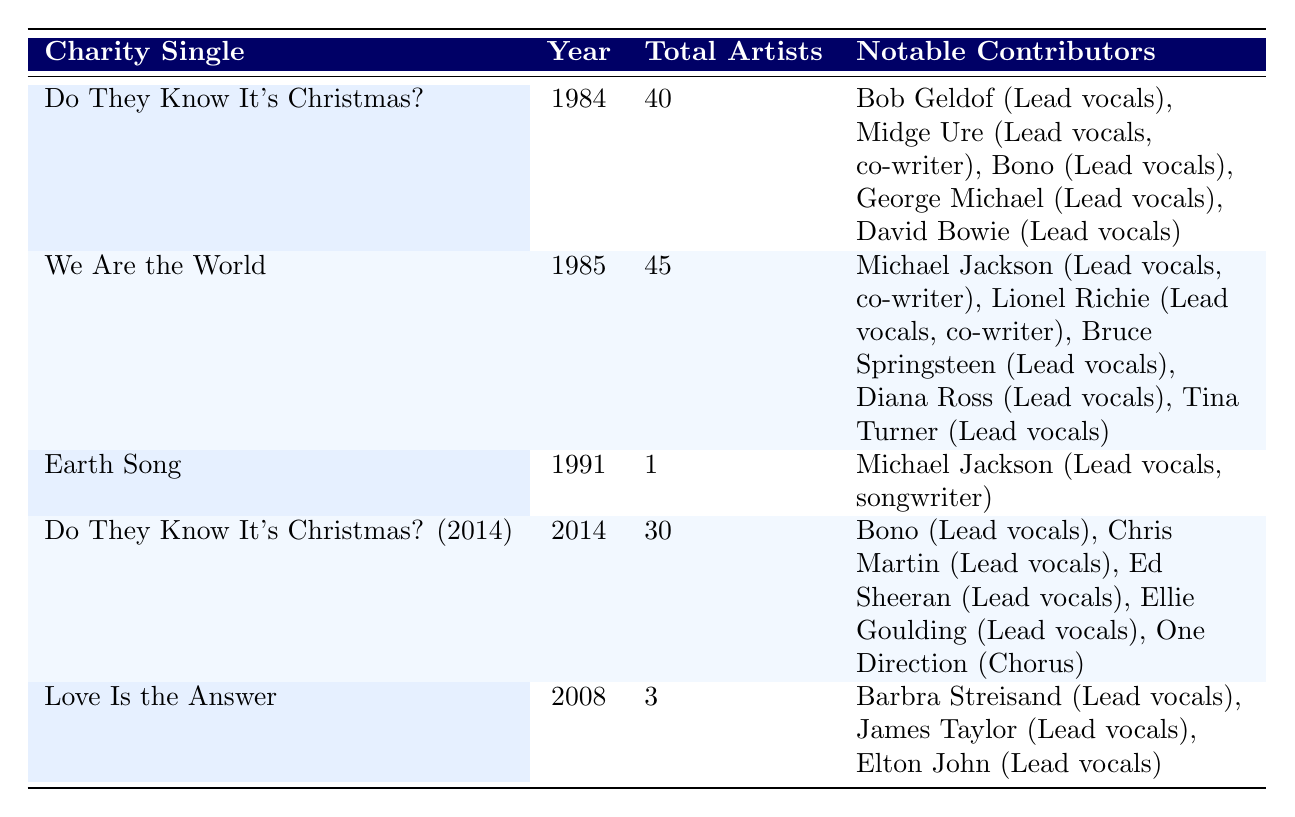What is the total number of artists involved in "We Are the World"? The table indicates that "We Are the World" has a total of 45 artists listed under the 'Total Artists' column.
Answer: 45 How many charity singles feature Michael Jackson? Michael Jackson is listed as a contributor for two charity singles: "We Are the World" and "Earth Song."
Answer: 2 Which charity single had the highest number of artists? By looking through the 'Total Artists' column, "We Are the World" shows the highest total at 45 artists.
Answer: We Are the World Is it true that "Love Is the Answer" has more artists than "Earth Song"? "Love Is the Answer" has 3 artists while "Earth Song" only has 1 artist. Thus, it is true that "Love Is the Answer" has more artists.
Answer: Yes What is the average number of artists across all five charity singles listed? The total number of artists across the singles is 40 (Do They Know It's Christmas?) + 45 (We Are the World) + 1 (Earth Song) + 30 (Do They Know It's Christmas? 2014) + 3 (Love Is the Answer) = 119 artists. There are 5 singles, so the average is 119/5 = 23.8.
Answer: 23.8 Which two charity singles were released in the 1980s? The years for the singles need to be compared: "Do They Know It's Christmas?" (1984) and "We Are the World" (1985) both fall within the 1980s decade.
Answer: Do They Know It's Christmas? and We Are the World How many artists collaborated on "Do They Know It's Christmas? (2014)" in comparison to its original version? The 2014 version has 30 artists while the original version has 40. Comparing these numbers shows a decrease of 10 artists in the 2014 version.
Answer: 10 fewer Which charity single features the fewest artists and what is the title? Looking at the 'Total Artists' column, "Earth Song" has the lowest total with only 1 artist listed.
Answer: Earth Song Is there a notable contributor from "Do They Know It's Christmas?" who also contributed to a later charity single, and if so, name that artist? Bono, who is a notable contributor for "Do They Know It's Christmas?", also contributed to the later charity single "Do They Know It's Christmas? (2014)."
Answer: Yes, Bono 